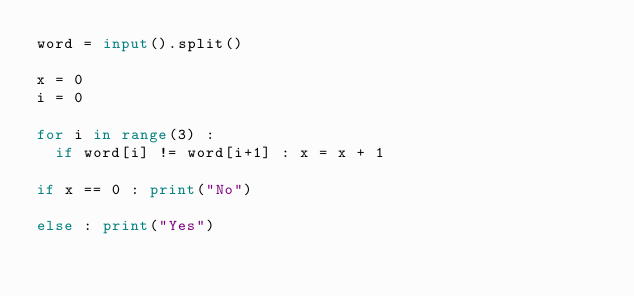Convert code to text. <code><loc_0><loc_0><loc_500><loc_500><_Python_>word = input().split()

x = 0
i = 0

for i in range(3) :
  if word[i] != word[i+1] : x = x + 1
    
if x == 0 : print("No")

else : print("Yes")</code> 